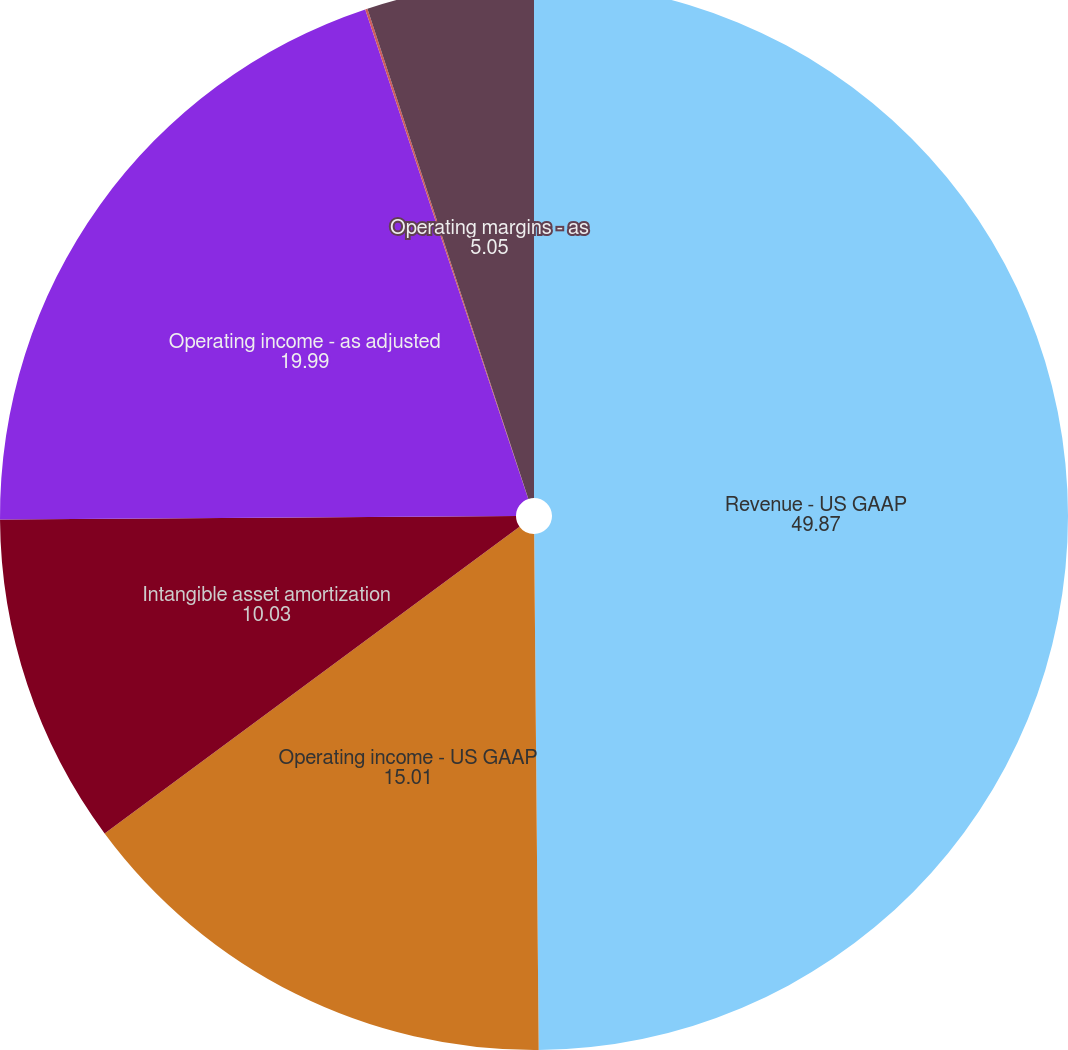Convert chart. <chart><loc_0><loc_0><loc_500><loc_500><pie_chart><fcel>Revenue - US GAAP<fcel>Operating income - US GAAP<fcel>Intangible asset amortization<fcel>Operating income - as adjusted<fcel>Operating margins - US GAAP<fcel>Operating margins - as<nl><fcel>49.87%<fcel>15.01%<fcel>10.03%<fcel>19.99%<fcel>0.07%<fcel>5.05%<nl></chart> 